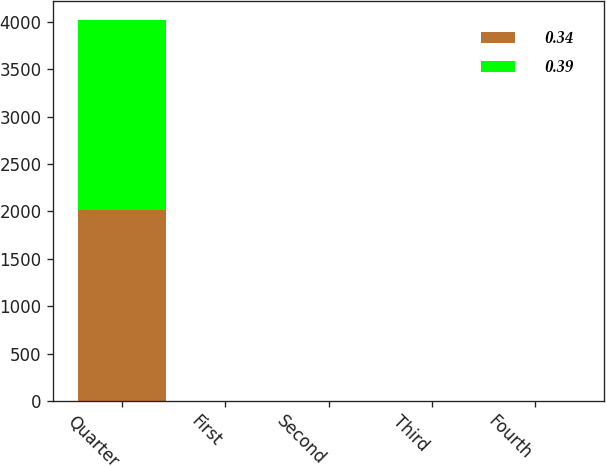Convert chart to OTSL. <chart><loc_0><loc_0><loc_500><loc_500><stacked_bar_chart><ecel><fcel>Quarter<fcel>First<fcel>Second<fcel>Third<fcel>Fourth<nl><fcel>0.34<fcel>2013<fcel>0.34<fcel>0.34<fcel>0.39<fcel>0.39<nl><fcel>0.39<fcel>2012<fcel>0.31<fcel>0.31<fcel>0.34<fcel>0.34<nl></chart> 